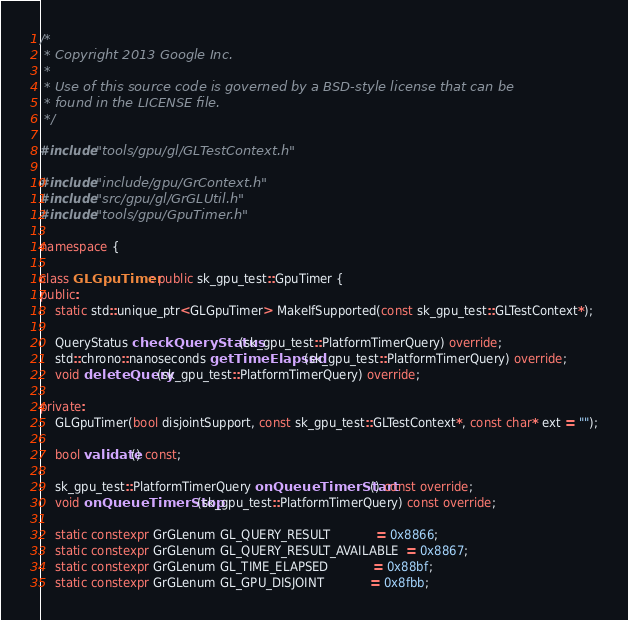Convert code to text. <code><loc_0><loc_0><loc_500><loc_500><_C++_>/*
 * Copyright 2013 Google Inc.
 *
 * Use of this source code is governed by a BSD-style license that can be
 * found in the LICENSE file.
 */

#include "tools/gpu/gl/GLTestContext.h"

#include "include/gpu/GrContext.h"
#include "src/gpu/gl/GrGLUtil.h"
#include "tools/gpu/GpuTimer.h"

namespace {

class GLGpuTimer : public sk_gpu_test::GpuTimer {
public:
    static std::unique_ptr<GLGpuTimer> MakeIfSupported(const sk_gpu_test::GLTestContext*);

    QueryStatus checkQueryStatus(sk_gpu_test::PlatformTimerQuery) override;
    std::chrono::nanoseconds getTimeElapsed(sk_gpu_test::PlatformTimerQuery) override;
    void deleteQuery(sk_gpu_test::PlatformTimerQuery) override;

private:
    GLGpuTimer(bool disjointSupport, const sk_gpu_test::GLTestContext*, const char* ext = "");

    bool validate() const;

    sk_gpu_test::PlatformTimerQuery onQueueTimerStart() const override;
    void onQueueTimerStop(sk_gpu_test::PlatformTimerQuery) const override;

    static constexpr GrGLenum GL_QUERY_RESULT            = 0x8866;
    static constexpr GrGLenum GL_QUERY_RESULT_AVAILABLE  = 0x8867;
    static constexpr GrGLenum GL_TIME_ELAPSED            = 0x88bf;
    static constexpr GrGLenum GL_GPU_DISJOINT            = 0x8fbb;
</code> 